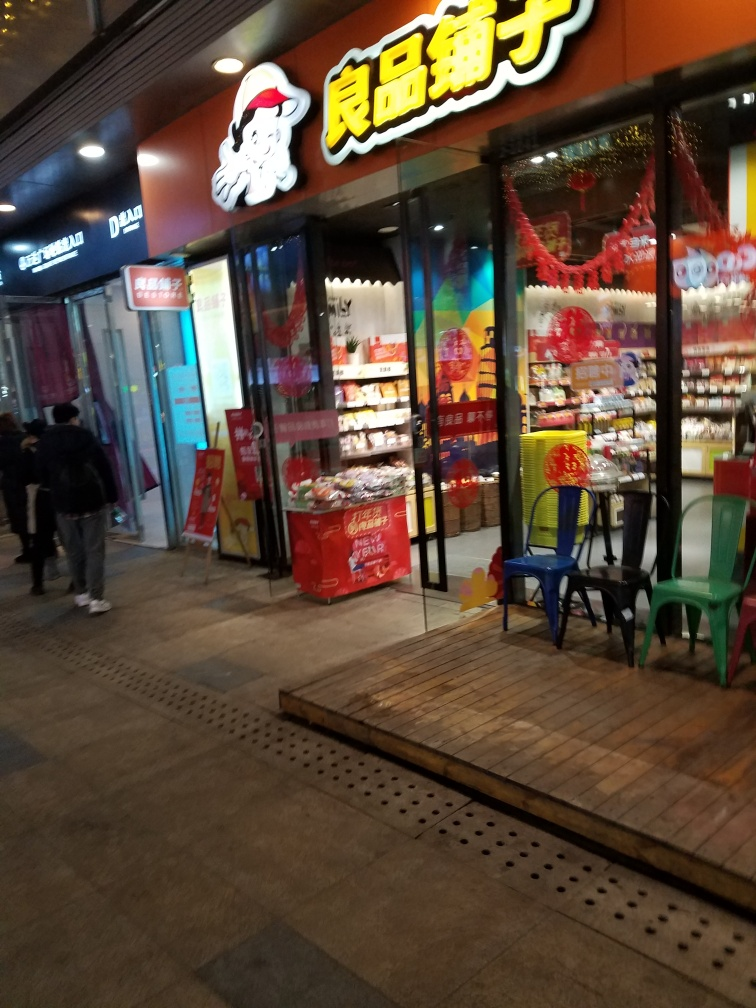What kind of products seem to be sold in this store? The store appears to sell an array of packaged goods, which might include snacks, confectionery, or localized specialty food items. The colorful packaging and the prominence of the displays suggest these items could be popular gifts or treats. Although the specifics are indistinct due to the photo's resolution and angle, the variety and presentation indicate a focus on attracting casual shoppers or tourists. 